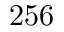Convert formula to latex. <formula><loc_0><loc_0><loc_500><loc_500>2 5 6</formula> 